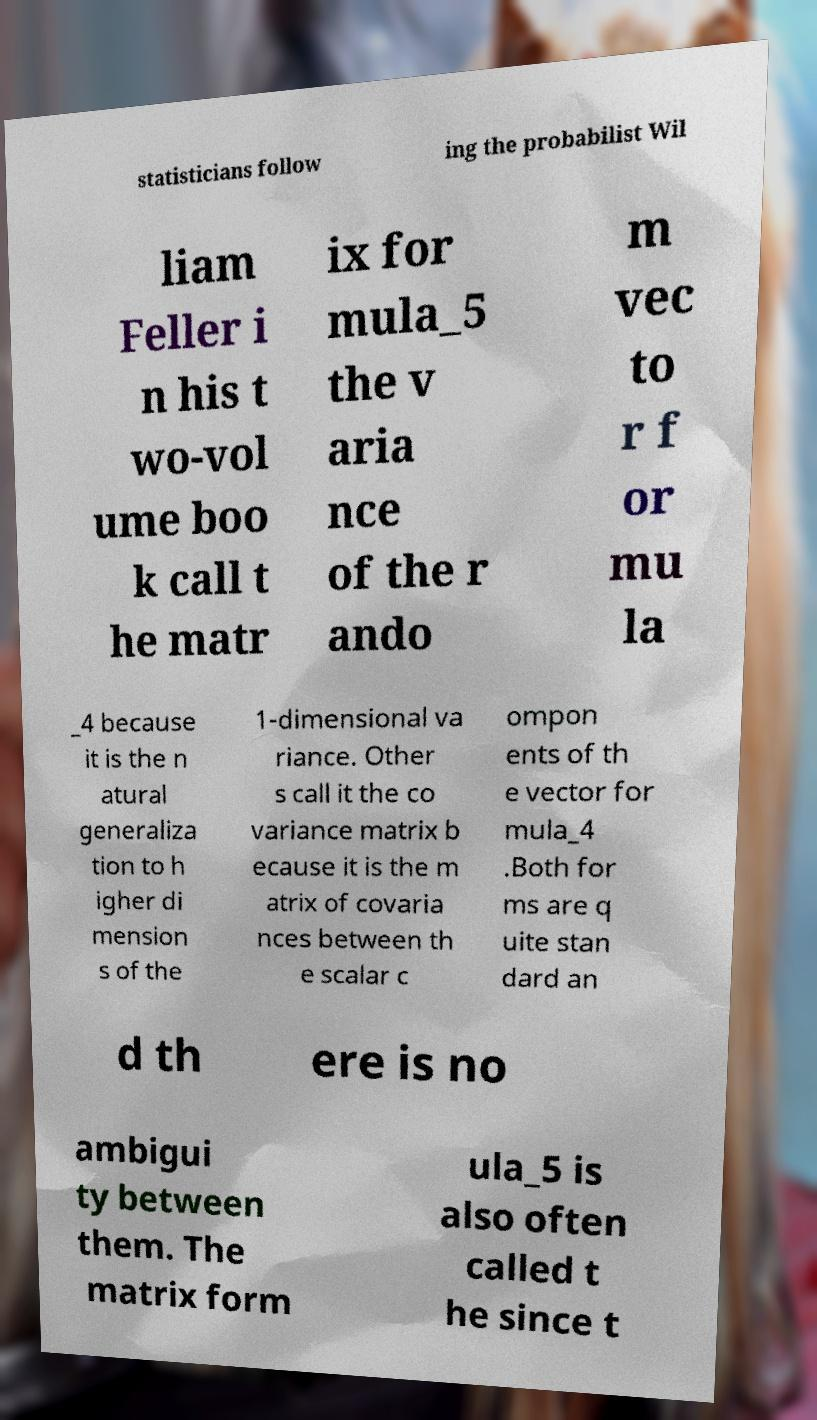Please read and relay the text visible in this image. What does it say? statisticians follow ing the probabilist Wil liam Feller i n his t wo-vol ume boo k call t he matr ix for mula_5 the v aria nce of the r ando m vec to r f or mu la _4 because it is the n atural generaliza tion to h igher di mension s of the 1-dimensional va riance. Other s call it the co variance matrix b ecause it is the m atrix of covaria nces between th e scalar c ompon ents of th e vector for mula_4 .Both for ms are q uite stan dard an d th ere is no ambigui ty between them. The matrix form ula_5 is also often called t he since t 